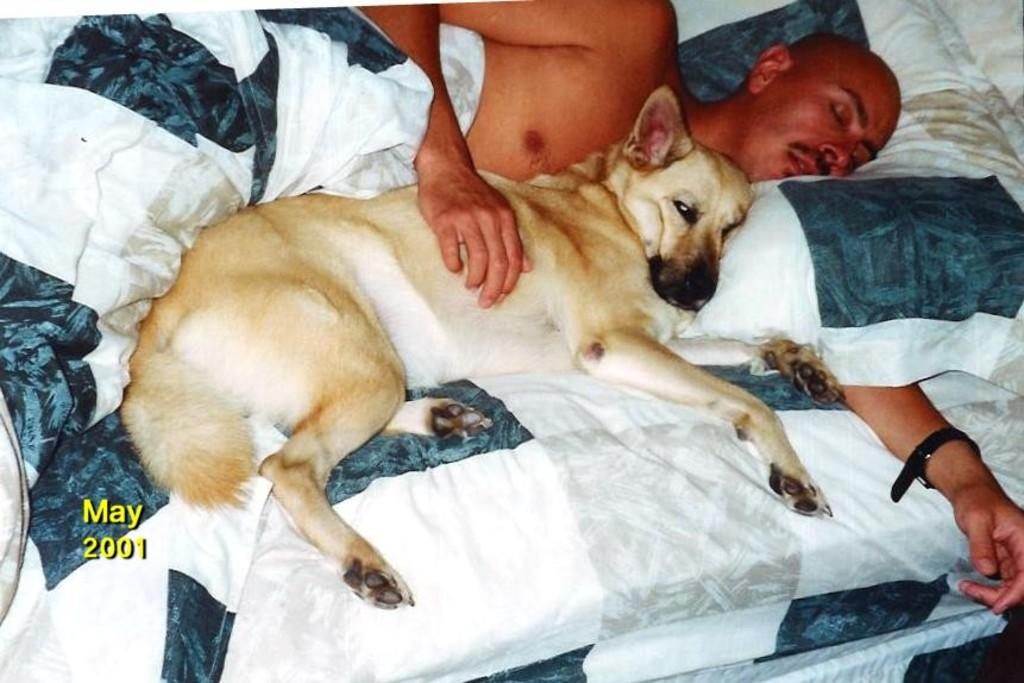Who is present in the image? There is a man in the image. What is the man doing in the image? The man is sleeping beside a dog on a bed. What is the man using to cover himself? The man is wrapped in a blanket. What type of basin is visible in the image? There is no basin present in the image. What punishment is the man receiving for his actions in the image? There is no indication of punishment in the image; the man is simply sleeping beside a dog on a bed. 